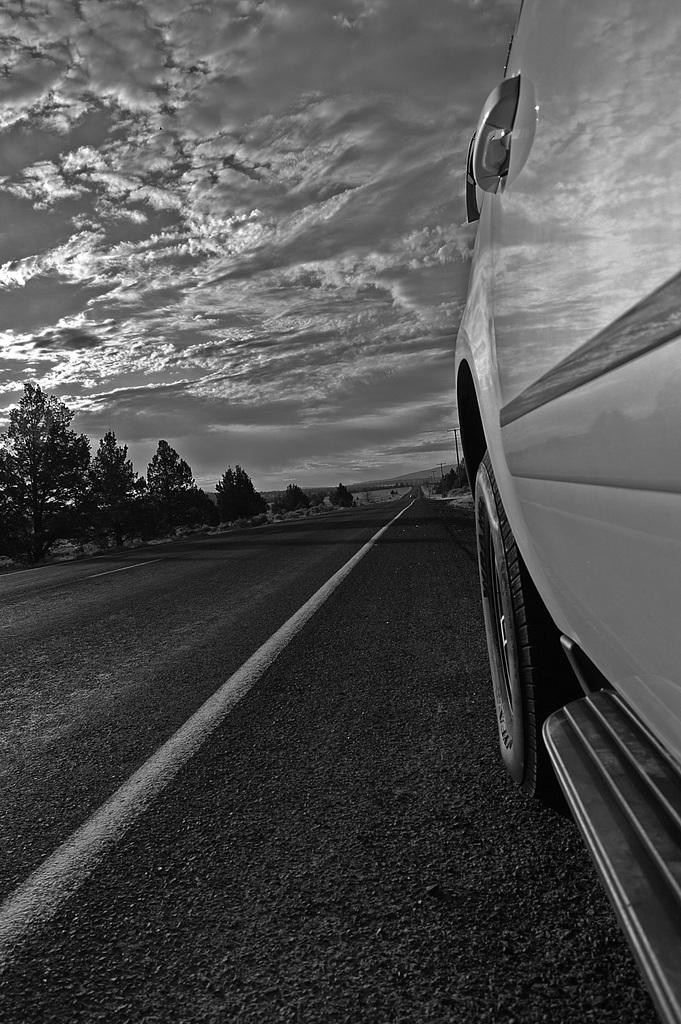What is on the road in the image? There is a vehicle on the road in the image. What type of natural features can be seen in the image? There are trees and mountains in the image. What is visible in the background of the image? The sky is visible in the background of the image. What can be seen in the sky? Clouds are present in the sky. Where is the ink spilled on the road in the image? There is no ink spilled on the road in the image. Can you see a frog hopping among the trees in the image? There is no frog present in the image. 